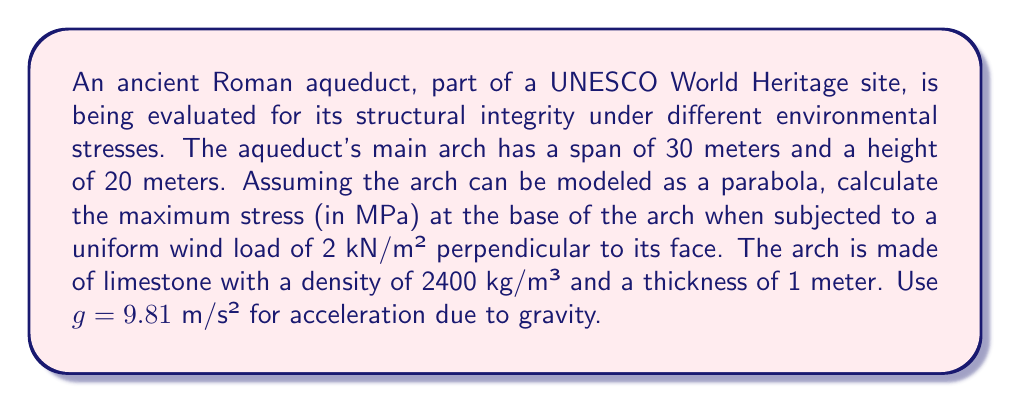Could you help me with this problem? To solve this problem, we'll follow these steps:

1) First, we need to model the arch as a parabola. The equation of a parabola with vertex at (0, h) is:

   $$y = -\frac{4h}{L^2}x^2 + h$$

   where $h = 20$ m (height) and $L = 30$ m (span).

2) The area of the arch can be calculated using the integral:

   $$A = \int_{-L/2}^{L/2} y \, dx = \int_{-15}^{15} \left(-\frac{4(20)}{30^2}x^2 + 20\right) \, dx = 400$ m²

3) The weight of the arch:

   $$W = \rho \cdot A \cdot t \cdot g = 2400 \cdot 400 \cdot 1 \cdot 9.81 = 9,417,600$ N

4) The wind force:

   $$F_w = 2000 \cdot A = 2000 \cdot 400 = 800,000$ N

5) The total force at the base:

   $$F_t = \sqrt{W^2 + F_w^2} = \sqrt{9,417,600^2 + 800,000^2} = 9,453,921$ N

6) The cross-sectional area at the base:

   $$A_b = 30 \cdot 1 = 30$ m²

7) The stress at the base:

   $$\sigma = \frac{F_t}{A_b} = \frac{9,453,921}{30} = 315,130.7$ N/m² = 315.13 MPa

Therefore, the maximum stress at the base of the arch is approximately 315.13 MPa.
Answer: 315.13 MPa 